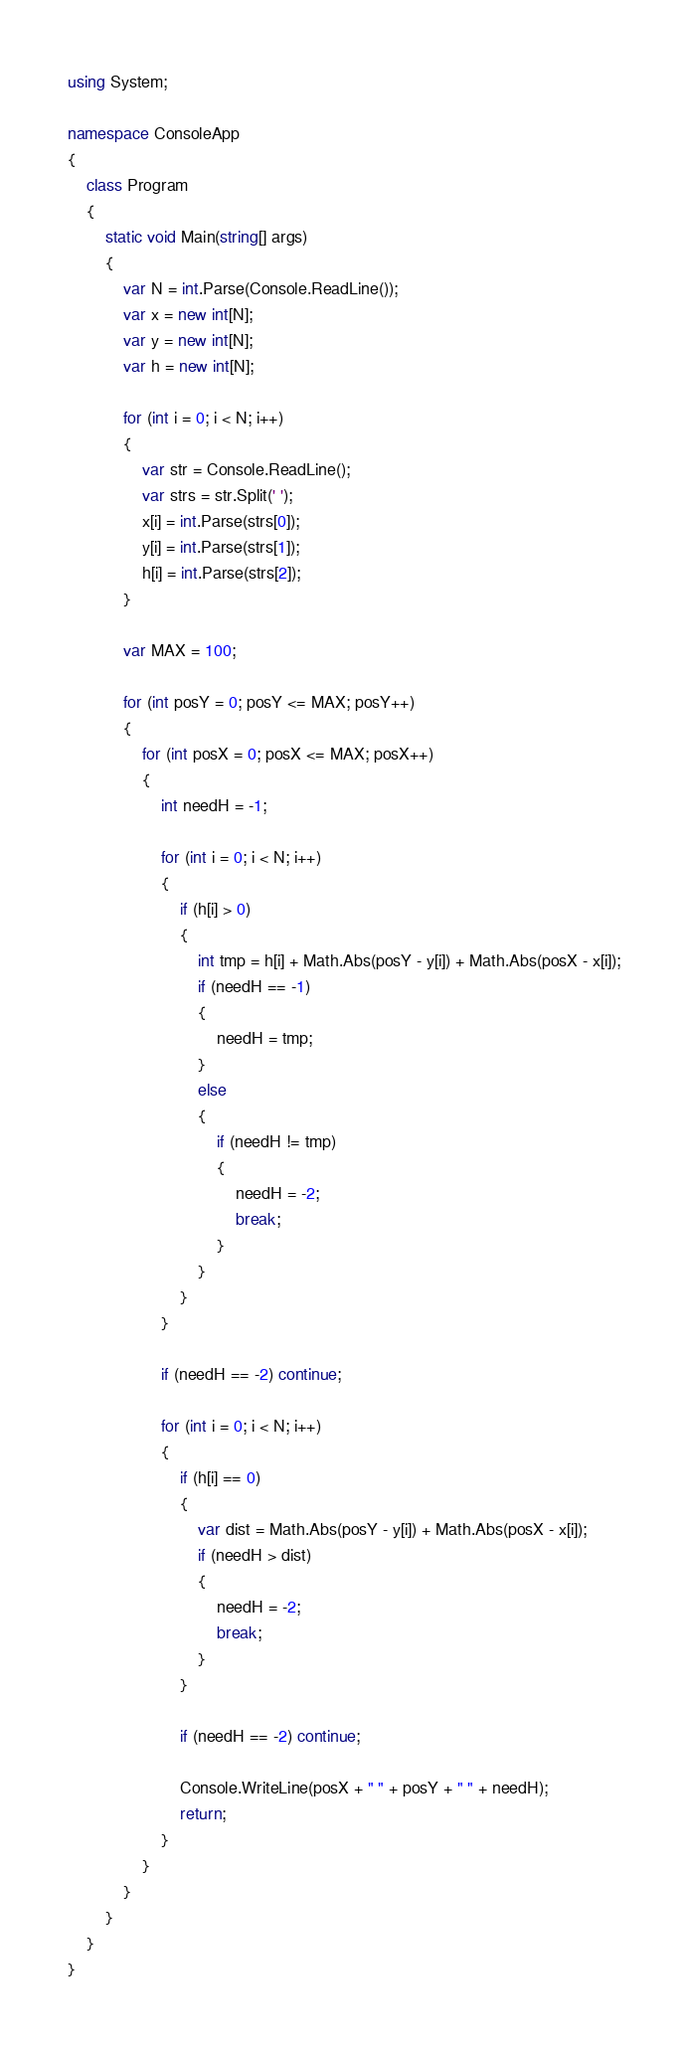<code> <loc_0><loc_0><loc_500><loc_500><_C#_>using System;

namespace ConsoleApp
{
    class Program
    {
        static void Main(string[] args)
        {
            var N = int.Parse(Console.ReadLine());
            var x = new int[N];
            var y = new int[N];
            var h = new int[N];

            for (int i = 0; i < N; i++)
            {
                var str = Console.ReadLine();
                var strs = str.Split(' ');
                x[i] = int.Parse(strs[0]);
                y[i] = int.Parse(strs[1]);
                h[i] = int.Parse(strs[2]);
            }

            var MAX = 100;

            for (int posY = 0; posY <= MAX; posY++)
            {
                for (int posX = 0; posX <= MAX; posX++)
                {
                    int needH = -1;

                    for (int i = 0; i < N; i++)
                    {
                        if (h[i] > 0)
                        {
                            int tmp = h[i] + Math.Abs(posY - y[i]) + Math.Abs(posX - x[i]);
                            if (needH == -1)
                            {
                                needH = tmp;
                            }
                            else
                            {
                                if (needH != tmp)
                                {
                                    needH = -2;
                                    break;
                                }
                            }
                        }
                    }

                    if (needH == -2) continue;

                    for (int i = 0; i < N; i++)
                    {
                        if (h[i] == 0)
                        {
                            var dist = Math.Abs(posY - y[i]) + Math.Abs(posX - x[i]);
                            if (needH > dist)
                            {
                                needH = -2;
                                break;
                            }
                        }

                        if (needH == -2) continue;

                        Console.WriteLine(posX + " " + posY + " " + needH);
                        return;
                    }
                }
            }
        }
    }
}
</code> 